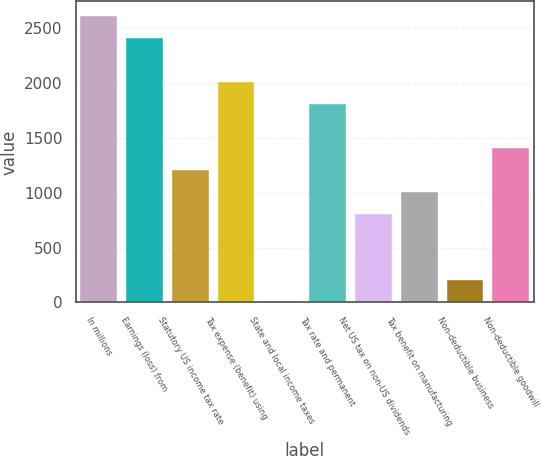Convert chart. <chart><loc_0><loc_0><loc_500><loc_500><bar_chart><fcel>In millions<fcel>Earnings (loss) from<fcel>Statutory US income tax rate<fcel>Tax expense (benefit) using<fcel>State and local income taxes<fcel>Tax rate and permanent<fcel>Net US tax on non-US dividends<fcel>Tax benefit on manufacturing<fcel>Non-deductible business<fcel>Non-deductible goodwill<nl><fcel>2616.3<fcel>2415.2<fcel>1208.6<fcel>2013<fcel>2<fcel>1811.9<fcel>806.4<fcel>1007.5<fcel>203.1<fcel>1409.7<nl></chart> 